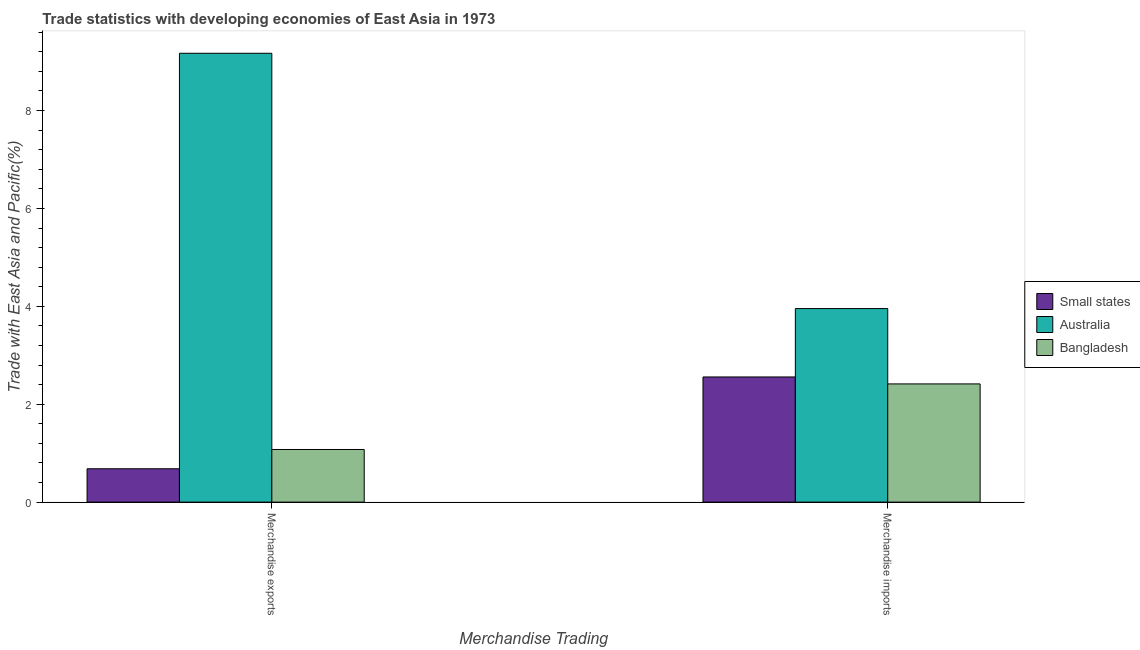How many different coloured bars are there?
Make the answer very short. 3. How many bars are there on the 1st tick from the left?
Your response must be concise. 3. How many bars are there on the 1st tick from the right?
Offer a terse response. 3. What is the label of the 1st group of bars from the left?
Offer a very short reply. Merchandise exports. What is the merchandise exports in Bangladesh?
Keep it short and to the point. 1.08. Across all countries, what is the maximum merchandise exports?
Your response must be concise. 9.17. Across all countries, what is the minimum merchandise exports?
Your response must be concise. 0.68. In which country was the merchandise exports minimum?
Your answer should be compact. Small states. What is the total merchandise imports in the graph?
Keep it short and to the point. 8.93. What is the difference between the merchandise exports in Bangladesh and that in Australia?
Keep it short and to the point. -8.09. What is the difference between the merchandise imports in Small states and the merchandise exports in Australia?
Offer a very short reply. -6.61. What is the average merchandise exports per country?
Offer a terse response. 3.64. What is the difference between the merchandise exports and merchandise imports in Small states?
Offer a very short reply. -1.88. In how many countries, is the merchandise imports greater than 7.6 %?
Provide a short and direct response. 0. What is the ratio of the merchandise imports in Australia to that in Small states?
Provide a succinct answer. 1.55. In how many countries, is the merchandise imports greater than the average merchandise imports taken over all countries?
Provide a short and direct response. 1. What does the 2nd bar from the right in Merchandise imports represents?
Give a very brief answer. Australia. How many countries are there in the graph?
Provide a short and direct response. 3. What is the difference between two consecutive major ticks on the Y-axis?
Provide a succinct answer. 2. Are the values on the major ticks of Y-axis written in scientific E-notation?
Provide a succinct answer. No. How many legend labels are there?
Your response must be concise. 3. How are the legend labels stacked?
Your response must be concise. Vertical. What is the title of the graph?
Offer a very short reply. Trade statistics with developing economies of East Asia in 1973. What is the label or title of the X-axis?
Give a very brief answer. Merchandise Trading. What is the label or title of the Y-axis?
Your answer should be compact. Trade with East Asia and Pacific(%). What is the Trade with East Asia and Pacific(%) of Small states in Merchandise exports?
Keep it short and to the point. 0.68. What is the Trade with East Asia and Pacific(%) in Australia in Merchandise exports?
Your response must be concise. 9.17. What is the Trade with East Asia and Pacific(%) in Bangladesh in Merchandise exports?
Ensure brevity in your answer.  1.08. What is the Trade with East Asia and Pacific(%) in Small states in Merchandise imports?
Your answer should be very brief. 2.56. What is the Trade with East Asia and Pacific(%) in Australia in Merchandise imports?
Keep it short and to the point. 3.95. What is the Trade with East Asia and Pacific(%) of Bangladesh in Merchandise imports?
Offer a terse response. 2.42. Across all Merchandise Trading, what is the maximum Trade with East Asia and Pacific(%) of Small states?
Ensure brevity in your answer.  2.56. Across all Merchandise Trading, what is the maximum Trade with East Asia and Pacific(%) of Australia?
Your answer should be compact. 9.17. Across all Merchandise Trading, what is the maximum Trade with East Asia and Pacific(%) of Bangladesh?
Your answer should be very brief. 2.42. Across all Merchandise Trading, what is the minimum Trade with East Asia and Pacific(%) in Small states?
Your answer should be very brief. 0.68. Across all Merchandise Trading, what is the minimum Trade with East Asia and Pacific(%) of Australia?
Offer a terse response. 3.95. Across all Merchandise Trading, what is the minimum Trade with East Asia and Pacific(%) of Bangladesh?
Provide a succinct answer. 1.08. What is the total Trade with East Asia and Pacific(%) of Small states in the graph?
Make the answer very short. 3.24. What is the total Trade with East Asia and Pacific(%) in Australia in the graph?
Make the answer very short. 13.12. What is the total Trade with East Asia and Pacific(%) in Bangladesh in the graph?
Make the answer very short. 3.49. What is the difference between the Trade with East Asia and Pacific(%) in Small states in Merchandise exports and that in Merchandise imports?
Your answer should be compact. -1.88. What is the difference between the Trade with East Asia and Pacific(%) of Australia in Merchandise exports and that in Merchandise imports?
Keep it short and to the point. 5.22. What is the difference between the Trade with East Asia and Pacific(%) in Bangladesh in Merchandise exports and that in Merchandise imports?
Your answer should be compact. -1.34. What is the difference between the Trade with East Asia and Pacific(%) in Small states in Merchandise exports and the Trade with East Asia and Pacific(%) in Australia in Merchandise imports?
Make the answer very short. -3.27. What is the difference between the Trade with East Asia and Pacific(%) of Small states in Merchandise exports and the Trade with East Asia and Pacific(%) of Bangladesh in Merchandise imports?
Provide a succinct answer. -1.73. What is the difference between the Trade with East Asia and Pacific(%) in Australia in Merchandise exports and the Trade with East Asia and Pacific(%) in Bangladesh in Merchandise imports?
Offer a terse response. 6.76. What is the average Trade with East Asia and Pacific(%) of Small states per Merchandise Trading?
Make the answer very short. 1.62. What is the average Trade with East Asia and Pacific(%) in Australia per Merchandise Trading?
Your answer should be compact. 6.56. What is the average Trade with East Asia and Pacific(%) of Bangladesh per Merchandise Trading?
Offer a terse response. 1.75. What is the difference between the Trade with East Asia and Pacific(%) in Small states and Trade with East Asia and Pacific(%) in Australia in Merchandise exports?
Your answer should be compact. -8.49. What is the difference between the Trade with East Asia and Pacific(%) of Small states and Trade with East Asia and Pacific(%) of Bangladesh in Merchandise exports?
Offer a very short reply. -0.39. What is the difference between the Trade with East Asia and Pacific(%) in Australia and Trade with East Asia and Pacific(%) in Bangladesh in Merchandise exports?
Your response must be concise. 8.09. What is the difference between the Trade with East Asia and Pacific(%) of Small states and Trade with East Asia and Pacific(%) of Australia in Merchandise imports?
Provide a succinct answer. -1.4. What is the difference between the Trade with East Asia and Pacific(%) of Small states and Trade with East Asia and Pacific(%) of Bangladesh in Merchandise imports?
Your response must be concise. 0.14. What is the difference between the Trade with East Asia and Pacific(%) of Australia and Trade with East Asia and Pacific(%) of Bangladesh in Merchandise imports?
Give a very brief answer. 1.54. What is the ratio of the Trade with East Asia and Pacific(%) in Small states in Merchandise exports to that in Merchandise imports?
Your response must be concise. 0.27. What is the ratio of the Trade with East Asia and Pacific(%) of Australia in Merchandise exports to that in Merchandise imports?
Provide a short and direct response. 2.32. What is the ratio of the Trade with East Asia and Pacific(%) in Bangladesh in Merchandise exports to that in Merchandise imports?
Your response must be concise. 0.45. What is the difference between the highest and the second highest Trade with East Asia and Pacific(%) in Small states?
Your answer should be compact. 1.88. What is the difference between the highest and the second highest Trade with East Asia and Pacific(%) in Australia?
Ensure brevity in your answer.  5.22. What is the difference between the highest and the second highest Trade with East Asia and Pacific(%) of Bangladesh?
Your response must be concise. 1.34. What is the difference between the highest and the lowest Trade with East Asia and Pacific(%) of Small states?
Your answer should be compact. 1.88. What is the difference between the highest and the lowest Trade with East Asia and Pacific(%) of Australia?
Give a very brief answer. 5.22. What is the difference between the highest and the lowest Trade with East Asia and Pacific(%) in Bangladesh?
Keep it short and to the point. 1.34. 